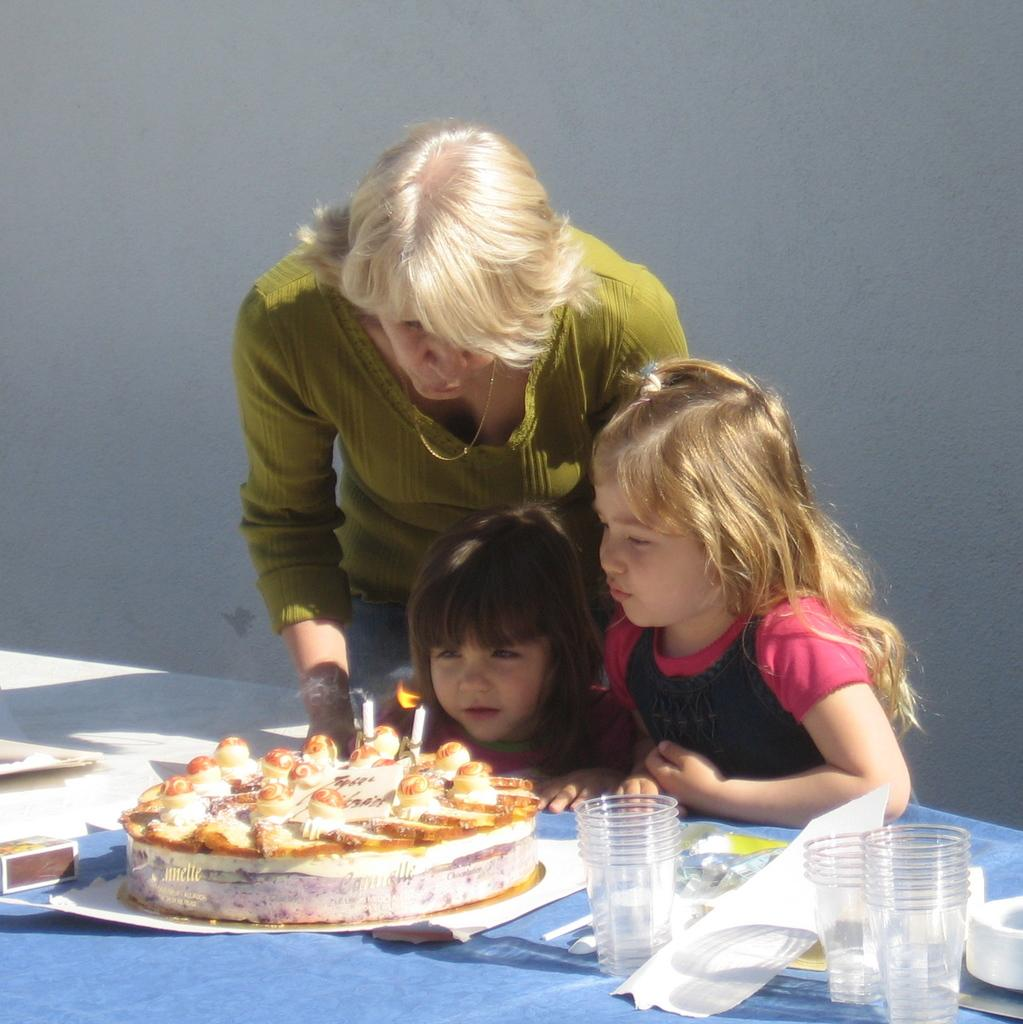What is the main piece of furniture in the image? There is a table in the image. What is placed on the table? A cake is placed on the table. What else can be seen on the table? There are glasses on the table. Who is present in the image? Two kids and a lady are standing behind the table. What are they doing? The lady and the kids are trying to blow the candle on the cake. How many alleys are visible in the image? There are no alleys present in the image. What rule is being enforced by the lady in the image? There is no indication of a rule being enforced in the image. 